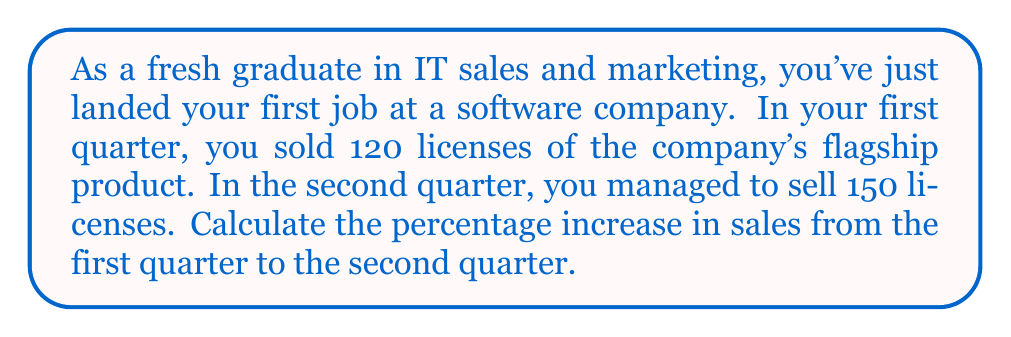Help me with this question. To calculate the percentage increase in sales, we need to follow these steps:

1. Calculate the difference between the new value and the original value:
   $\text{Difference} = \text{New Value} - \text{Original Value}$
   $\text{Difference} = 150 - 120 = 30$

2. Divide the difference by the original value:
   $\frac{\text{Difference}}{\text{Original Value}} = \frac{30}{120} = 0.25$

3. Multiply the result by 100 to get the percentage:
   $\text{Percentage Increase} = 0.25 \times 100 = 25\%$

We can express this calculation as a single formula:

$$\text{Percentage Increase} = \frac{\text{New Value} - \text{Original Value}}{\text{Original Value}} \times 100\%$$

Plugging in our values:

$$\text{Percentage Increase} = \frac{150 - 120}{120} \times 100\% = \frac{30}{120} \times 100\% = 0.25 \times 100\% = 25\%$$

Therefore, the percentage increase in sales from the first quarter to the second quarter is 25%.
Answer: 25% 